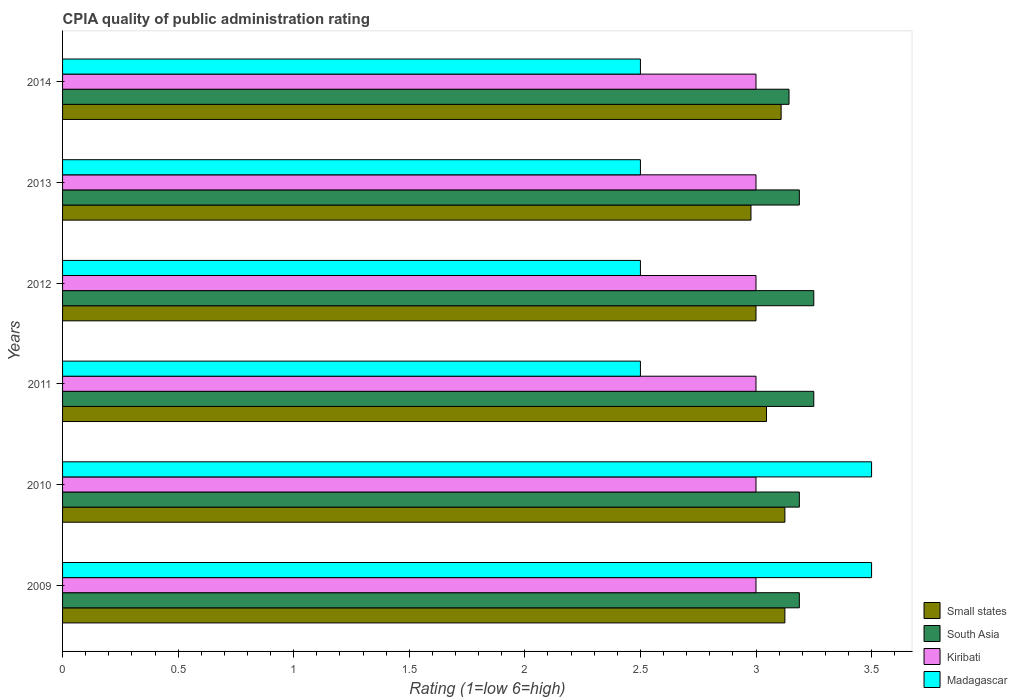How many groups of bars are there?
Give a very brief answer. 6. Are the number of bars per tick equal to the number of legend labels?
Keep it short and to the point. Yes. How many bars are there on the 6th tick from the top?
Give a very brief answer. 4. What is the label of the 1st group of bars from the top?
Keep it short and to the point. 2014. In how many cases, is the number of bars for a given year not equal to the number of legend labels?
Ensure brevity in your answer.  0. What is the CPIA rating in Madagascar in 2012?
Your answer should be compact. 2.5. Across all years, what is the maximum CPIA rating in Madagascar?
Your answer should be very brief. 3.5. Across all years, what is the minimum CPIA rating in Madagascar?
Ensure brevity in your answer.  2.5. What is the total CPIA rating in South Asia in the graph?
Offer a very short reply. 19.21. What is the difference between the CPIA rating in Small states in 2009 and that in 2014?
Offer a very short reply. 0.02. What is the average CPIA rating in Small states per year?
Make the answer very short. 3.06. In the year 2014, what is the difference between the CPIA rating in Kiribati and CPIA rating in South Asia?
Offer a terse response. -0.14. Is the difference between the CPIA rating in Kiribati in 2012 and 2014 greater than the difference between the CPIA rating in South Asia in 2012 and 2014?
Provide a short and direct response. No. What is the difference between the highest and the lowest CPIA rating in South Asia?
Keep it short and to the point. 0.11. In how many years, is the CPIA rating in Kiribati greater than the average CPIA rating in Kiribati taken over all years?
Provide a short and direct response. 0. What does the 1st bar from the top in 2011 represents?
Provide a succinct answer. Madagascar. What does the 3rd bar from the bottom in 2014 represents?
Ensure brevity in your answer.  Kiribati. Is it the case that in every year, the sum of the CPIA rating in Madagascar and CPIA rating in Small states is greater than the CPIA rating in South Asia?
Offer a terse response. Yes. How many bars are there?
Give a very brief answer. 24. Are all the bars in the graph horizontal?
Provide a succinct answer. Yes. Are the values on the major ticks of X-axis written in scientific E-notation?
Ensure brevity in your answer.  No. Does the graph contain any zero values?
Give a very brief answer. No. How are the legend labels stacked?
Provide a short and direct response. Vertical. What is the title of the graph?
Ensure brevity in your answer.  CPIA quality of public administration rating. Does "Grenada" appear as one of the legend labels in the graph?
Your answer should be compact. No. What is the label or title of the X-axis?
Keep it short and to the point. Rating (1=low 6=high). What is the label or title of the Y-axis?
Ensure brevity in your answer.  Years. What is the Rating (1=low 6=high) in Small states in 2009?
Your answer should be very brief. 3.12. What is the Rating (1=low 6=high) of South Asia in 2009?
Provide a succinct answer. 3.19. What is the Rating (1=low 6=high) of Madagascar in 2009?
Your answer should be very brief. 3.5. What is the Rating (1=low 6=high) in Small states in 2010?
Keep it short and to the point. 3.12. What is the Rating (1=low 6=high) in South Asia in 2010?
Provide a short and direct response. 3.19. What is the Rating (1=low 6=high) of Small states in 2011?
Offer a terse response. 3.05. What is the Rating (1=low 6=high) of South Asia in 2011?
Make the answer very short. 3.25. What is the Rating (1=low 6=high) of Madagascar in 2011?
Your answer should be very brief. 2.5. What is the Rating (1=low 6=high) of Small states in 2012?
Provide a short and direct response. 3. What is the Rating (1=low 6=high) in South Asia in 2012?
Your response must be concise. 3.25. What is the Rating (1=low 6=high) in Madagascar in 2012?
Your answer should be very brief. 2.5. What is the Rating (1=low 6=high) in Small states in 2013?
Make the answer very short. 2.98. What is the Rating (1=low 6=high) of South Asia in 2013?
Offer a very short reply. 3.19. What is the Rating (1=low 6=high) of Kiribati in 2013?
Give a very brief answer. 3. What is the Rating (1=low 6=high) of Madagascar in 2013?
Offer a very short reply. 2.5. What is the Rating (1=low 6=high) of Small states in 2014?
Your answer should be very brief. 3.11. What is the Rating (1=low 6=high) of South Asia in 2014?
Give a very brief answer. 3.14. What is the Rating (1=low 6=high) in Kiribati in 2014?
Provide a short and direct response. 3. What is the Rating (1=low 6=high) of Madagascar in 2014?
Your answer should be compact. 2.5. Across all years, what is the maximum Rating (1=low 6=high) in Small states?
Your response must be concise. 3.12. Across all years, what is the minimum Rating (1=low 6=high) in Small states?
Your answer should be very brief. 2.98. Across all years, what is the minimum Rating (1=low 6=high) in South Asia?
Ensure brevity in your answer.  3.14. What is the total Rating (1=low 6=high) of Small states in the graph?
Your answer should be compact. 18.38. What is the total Rating (1=low 6=high) in South Asia in the graph?
Give a very brief answer. 19.21. What is the total Rating (1=low 6=high) in Madagascar in the graph?
Offer a terse response. 17. What is the difference between the Rating (1=low 6=high) in Small states in 2009 and that in 2010?
Provide a succinct answer. 0. What is the difference between the Rating (1=low 6=high) of South Asia in 2009 and that in 2010?
Your response must be concise. 0. What is the difference between the Rating (1=low 6=high) of Madagascar in 2009 and that in 2010?
Your response must be concise. 0. What is the difference between the Rating (1=low 6=high) of Small states in 2009 and that in 2011?
Your answer should be compact. 0.08. What is the difference between the Rating (1=low 6=high) of South Asia in 2009 and that in 2011?
Ensure brevity in your answer.  -0.06. What is the difference between the Rating (1=low 6=high) in Madagascar in 2009 and that in 2011?
Your answer should be compact. 1. What is the difference between the Rating (1=low 6=high) in Small states in 2009 and that in 2012?
Offer a terse response. 0.12. What is the difference between the Rating (1=low 6=high) of South Asia in 2009 and that in 2012?
Give a very brief answer. -0.06. What is the difference between the Rating (1=low 6=high) in Kiribati in 2009 and that in 2012?
Give a very brief answer. 0. What is the difference between the Rating (1=low 6=high) of Small states in 2009 and that in 2013?
Your answer should be very brief. 0.15. What is the difference between the Rating (1=low 6=high) in Small states in 2009 and that in 2014?
Your response must be concise. 0.02. What is the difference between the Rating (1=low 6=high) in South Asia in 2009 and that in 2014?
Your answer should be compact. 0.04. What is the difference between the Rating (1=low 6=high) of Madagascar in 2009 and that in 2014?
Keep it short and to the point. 1. What is the difference between the Rating (1=low 6=high) of Small states in 2010 and that in 2011?
Provide a succinct answer. 0.08. What is the difference between the Rating (1=low 6=high) in South Asia in 2010 and that in 2011?
Provide a succinct answer. -0.06. What is the difference between the Rating (1=low 6=high) in South Asia in 2010 and that in 2012?
Your answer should be compact. -0.06. What is the difference between the Rating (1=low 6=high) in Small states in 2010 and that in 2013?
Keep it short and to the point. 0.15. What is the difference between the Rating (1=low 6=high) in Kiribati in 2010 and that in 2013?
Give a very brief answer. 0. What is the difference between the Rating (1=low 6=high) in Small states in 2010 and that in 2014?
Give a very brief answer. 0.02. What is the difference between the Rating (1=low 6=high) of South Asia in 2010 and that in 2014?
Give a very brief answer. 0.04. What is the difference between the Rating (1=low 6=high) of Small states in 2011 and that in 2012?
Keep it short and to the point. 0.05. What is the difference between the Rating (1=low 6=high) of Kiribati in 2011 and that in 2012?
Offer a terse response. 0. What is the difference between the Rating (1=low 6=high) in Madagascar in 2011 and that in 2012?
Offer a very short reply. 0. What is the difference between the Rating (1=low 6=high) of Small states in 2011 and that in 2013?
Keep it short and to the point. 0.07. What is the difference between the Rating (1=low 6=high) in South Asia in 2011 and that in 2013?
Make the answer very short. 0.06. What is the difference between the Rating (1=low 6=high) of Kiribati in 2011 and that in 2013?
Your response must be concise. 0. What is the difference between the Rating (1=low 6=high) in Small states in 2011 and that in 2014?
Your answer should be compact. -0.06. What is the difference between the Rating (1=low 6=high) of South Asia in 2011 and that in 2014?
Provide a short and direct response. 0.11. What is the difference between the Rating (1=low 6=high) in Kiribati in 2011 and that in 2014?
Your answer should be compact. 0. What is the difference between the Rating (1=low 6=high) of Madagascar in 2011 and that in 2014?
Your answer should be compact. 0. What is the difference between the Rating (1=low 6=high) in Small states in 2012 and that in 2013?
Give a very brief answer. 0.02. What is the difference between the Rating (1=low 6=high) in South Asia in 2012 and that in 2013?
Provide a short and direct response. 0.06. What is the difference between the Rating (1=low 6=high) in Madagascar in 2012 and that in 2013?
Ensure brevity in your answer.  0. What is the difference between the Rating (1=low 6=high) of Small states in 2012 and that in 2014?
Provide a short and direct response. -0.11. What is the difference between the Rating (1=low 6=high) in South Asia in 2012 and that in 2014?
Your answer should be very brief. 0.11. What is the difference between the Rating (1=low 6=high) of Small states in 2013 and that in 2014?
Your answer should be compact. -0.13. What is the difference between the Rating (1=low 6=high) in South Asia in 2013 and that in 2014?
Provide a short and direct response. 0.04. What is the difference between the Rating (1=low 6=high) of Kiribati in 2013 and that in 2014?
Make the answer very short. 0. What is the difference between the Rating (1=low 6=high) in Madagascar in 2013 and that in 2014?
Your response must be concise. 0. What is the difference between the Rating (1=low 6=high) in Small states in 2009 and the Rating (1=low 6=high) in South Asia in 2010?
Your answer should be very brief. -0.06. What is the difference between the Rating (1=low 6=high) of Small states in 2009 and the Rating (1=low 6=high) of Madagascar in 2010?
Make the answer very short. -0.38. What is the difference between the Rating (1=low 6=high) in South Asia in 2009 and the Rating (1=low 6=high) in Kiribati in 2010?
Provide a short and direct response. 0.19. What is the difference between the Rating (1=low 6=high) of South Asia in 2009 and the Rating (1=low 6=high) of Madagascar in 2010?
Make the answer very short. -0.31. What is the difference between the Rating (1=low 6=high) in Small states in 2009 and the Rating (1=low 6=high) in South Asia in 2011?
Offer a very short reply. -0.12. What is the difference between the Rating (1=low 6=high) in South Asia in 2009 and the Rating (1=low 6=high) in Kiribati in 2011?
Give a very brief answer. 0.19. What is the difference between the Rating (1=low 6=high) in South Asia in 2009 and the Rating (1=low 6=high) in Madagascar in 2011?
Provide a succinct answer. 0.69. What is the difference between the Rating (1=low 6=high) of Kiribati in 2009 and the Rating (1=low 6=high) of Madagascar in 2011?
Make the answer very short. 0.5. What is the difference between the Rating (1=low 6=high) of Small states in 2009 and the Rating (1=low 6=high) of South Asia in 2012?
Your response must be concise. -0.12. What is the difference between the Rating (1=low 6=high) in Small states in 2009 and the Rating (1=low 6=high) in Kiribati in 2012?
Provide a succinct answer. 0.12. What is the difference between the Rating (1=low 6=high) of South Asia in 2009 and the Rating (1=low 6=high) of Kiribati in 2012?
Keep it short and to the point. 0.19. What is the difference between the Rating (1=low 6=high) of South Asia in 2009 and the Rating (1=low 6=high) of Madagascar in 2012?
Give a very brief answer. 0.69. What is the difference between the Rating (1=low 6=high) in Small states in 2009 and the Rating (1=low 6=high) in South Asia in 2013?
Ensure brevity in your answer.  -0.06. What is the difference between the Rating (1=low 6=high) of South Asia in 2009 and the Rating (1=low 6=high) of Kiribati in 2013?
Your answer should be compact. 0.19. What is the difference between the Rating (1=low 6=high) in South Asia in 2009 and the Rating (1=low 6=high) in Madagascar in 2013?
Give a very brief answer. 0.69. What is the difference between the Rating (1=low 6=high) in Small states in 2009 and the Rating (1=low 6=high) in South Asia in 2014?
Give a very brief answer. -0.02. What is the difference between the Rating (1=low 6=high) in Small states in 2009 and the Rating (1=low 6=high) in Kiribati in 2014?
Your answer should be compact. 0.12. What is the difference between the Rating (1=low 6=high) in South Asia in 2009 and the Rating (1=low 6=high) in Kiribati in 2014?
Give a very brief answer. 0.19. What is the difference between the Rating (1=low 6=high) in South Asia in 2009 and the Rating (1=low 6=high) in Madagascar in 2014?
Your response must be concise. 0.69. What is the difference between the Rating (1=low 6=high) in Small states in 2010 and the Rating (1=low 6=high) in South Asia in 2011?
Your response must be concise. -0.12. What is the difference between the Rating (1=low 6=high) in Small states in 2010 and the Rating (1=low 6=high) in Kiribati in 2011?
Provide a succinct answer. 0.12. What is the difference between the Rating (1=low 6=high) in Small states in 2010 and the Rating (1=low 6=high) in Madagascar in 2011?
Offer a very short reply. 0.62. What is the difference between the Rating (1=low 6=high) of South Asia in 2010 and the Rating (1=low 6=high) of Kiribati in 2011?
Your response must be concise. 0.19. What is the difference between the Rating (1=low 6=high) in South Asia in 2010 and the Rating (1=low 6=high) in Madagascar in 2011?
Ensure brevity in your answer.  0.69. What is the difference between the Rating (1=low 6=high) of Small states in 2010 and the Rating (1=low 6=high) of South Asia in 2012?
Provide a short and direct response. -0.12. What is the difference between the Rating (1=low 6=high) in Small states in 2010 and the Rating (1=low 6=high) in Madagascar in 2012?
Provide a short and direct response. 0.62. What is the difference between the Rating (1=low 6=high) of South Asia in 2010 and the Rating (1=low 6=high) of Kiribati in 2012?
Keep it short and to the point. 0.19. What is the difference between the Rating (1=low 6=high) in South Asia in 2010 and the Rating (1=low 6=high) in Madagascar in 2012?
Your answer should be very brief. 0.69. What is the difference between the Rating (1=low 6=high) in Kiribati in 2010 and the Rating (1=low 6=high) in Madagascar in 2012?
Make the answer very short. 0.5. What is the difference between the Rating (1=low 6=high) of Small states in 2010 and the Rating (1=low 6=high) of South Asia in 2013?
Keep it short and to the point. -0.06. What is the difference between the Rating (1=low 6=high) of South Asia in 2010 and the Rating (1=low 6=high) of Kiribati in 2013?
Offer a very short reply. 0.19. What is the difference between the Rating (1=low 6=high) in South Asia in 2010 and the Rating (1=low 6=high) in Madagascar in 2013?
Make the answer very short. 0.69. What is the difference between the Rating (1=low 6=high) of Small states in 2010 and the Rating (1=low 6=high) of South Asia in 2014?
Ensure brevity in your answer.  -0.02. What is the difference between the Rating (1=low 6=high) in Small states in 2010 and the Rating (1=low 6=high) in Kiribati in 2014?
Give a very brief answer. 0.12. What is the difference between the Rating (1=low 6=high) of South Asia in 2010 and the Rating (1=low 6=high) of Kiribati in 2014?
Offer a terse response. 0.19. What is the difference between the Rating (1=low 6=high) of South Asia in 2010 and the Rating (1=low 6=high) of Madagascar in 2014?
Keep it short and to the point. 0.69. What is the difference between the Rating (1=low 6=high) in Small states in 2011 and the Rating (1=low 6=high) in South Asia in 2012?
Make the answer very short. -0.2. What is the difference between the Rating (1=low 6=high) in Small states in 2011 and the Rating (1=low 6=high) in Kiribati in 2012?
Offer a very short reply. 0.05. What is the difference between the Rating (1=low 6=high) of Small states in 2011 and the Rating (1=low 6=high) of Madagascar in 2012?
Your answer should be very brief. 0.55. What is the difference between the Rating (1=low 6=high) of South Asia in 2011 and the Rating (1=low 6=high) of Kiribati in 2012?
Your answer should be very brief. 0.25. What is the difference between the Rating (1=low 6=high) in South Asia in 2011 and the Rating (1=low 6=high) in Madagascar in 2012?
Provide a succinct answer. 0.75. What is the difference between the Rating (1=low 6=high) of Kiribati in 2011 and the Rating (1=low 6=high) of Madagascar in 2012?
Keep it short and to the point. 0.5. What is the difference between the Rating (1=low 6=high) of Small states in 2011 and the Rating (1=low 6=high) of South Asia in 2013?
Offer a terse response. -0.14. What is the difference between the Rating (1=low 6=high) of Small states in 2011 and the Rating (1=low 6=high) of Kiribati in 2013?
Make the answer very short. 0.05. What is the difference between the Rating (1=low 6=high) of Small states in 2011 and the Rating (1=low 6=high) of Madagascar in 2013?
Keep it short and to the point. 0.55. What is the difference between the Rating (1=low 6=high) in South Asia in 2011 and the Rating (1=low 6=high) in Kiribati in 2013?
Keep it short and to the point. 0.25. What is the difference between the Rating (1=low 6=high) of Small states in 2011 and the Rating (1=low 6=high) of South Asia in 2014?
Ensure brevity in your answer.  -0.1. What is the difference between the Rating (1=low 6=high) of Small states in 2011 and the Rating (1=low 6=high) of Kiribati in 2014?
Offer a very short reply. 0.05. What is the difference between the Rating (1=low 6=high) in Small states in 2011 and the Rating (1=low 6=high) in Madagascar in 2014?
Offer a very short reply. 0.55. What is the difference between the Rating (1=low 6=high) of South Asia in 2011 and the Rating (1=low 6=high) of Kiribati in 2014?
Offer a very short reply. 0.25. What is the difference between the Rating (1=low 6=high) in Kiribati in 2011 and the Rating (1=low 6=high) in Madagascar in 2014?
Keep it short and to the point. 0.5. What is the difference between the Rating (1=low 6=high) in Small states in 2012 and the Rating (1=low 6=high) in South Asia in 2013?
Your response must be concise. -0.19. What is the difference between the Rating (1=low 6=high) in Small states in 2012 and the Rating (1=low 6=high) in Kiribati in 2013?
Offer a terse response. 0. What is the difference between the Rating (1=low 6=high) in Kiribati in 2012 and the Rating (1=low 6=high) in Madagascar in 2013?
Ensure brevity in your answer.  0.5. What is the difference between the Rating (1=low 6=high) in Small states in 2012 and the Rating (1=low 6=high) in South Asia in 2014?
Provide a short and direct response. -0.14. What is the difference between the Rating (1=low 6=high) in Small states in 2012 and the Rating (1=low 6=high) in Madagascar in 2014?
Your response must be concise. 0.5. What is the difference between the Rating (1=low 6=high) of South Asia in 2012 and the Rating (1=low 6=high) of Kiribati in 2014?
Offer a terse response. 0.25. What is the difference between the Rating (1=low 6=high) in South Asia in 2012 and the Rating (1=low 6=high) in Madagascar in 2014?
Offer a terse response. 0.75. What is the difference between the Rating (1=low 6=high) of Small states in 2013 and the Rating (1=low 6=high) of South Asia in 2014?
Make the answer very short. -0.16. What is the difference between the Rating (1=low 6=high) of Small states in 2013 and the Rating (1=low 6=high) of Kiribati in 2014?
Give a very brief answer. -0.02. What is the difference between the Rating (1=low 6=high) of Small states in 2013 and the Rating (1=low 6=high) of Madagascar in 2014?
Provide a short and direct response. 0.48. What is the difference between the Rating (1=low 6=high) in South Asia in 2013 and the Rating (1=low 6=high) in Kiribati in 2014?
Give a very brief answer. 0.19. What is the difference between the Rating (1=low 6=high) in South Asia in 2013 and the Rating (1=low 6=high) in Madagascar in 2014?
Your answer should be very brief. 0.69. What is the average Rating (1=low 6=high) of Small states per year?
Make the answer very short. 3.06. What is the average Rating (1=low 6=high) in South Asia per year?
Keep it short and to the point. 3.2. What is the average Rating (1=low 6=high) of Kiribati per year?
Your answer should be very brief. 3. What is the average Rating (1=low 6=high) in Madagascar per year?
Give a very brief answer. 2.83. In the year 2009, what is the difference between the Rating (1=low 6=high) of Small states and Rating (1=low 6=high) of South Asia?
Provide a short and direct response. -0.06. In the year 2009, what is the difference between the Rating (1=low 6=high) in Small states and Rating (1=low 6=high) in Madagascar?
Offer a very short reply. -0.38. In the year 2009, what is the difference between the Rating (1=low 6=high) in South Asia and Rating (1=low 6=high) in Kiribati?
Your response must be concise. 0.19. In the year 2009, what is the difference between the Rating (1=low 6=high) of South Asia and Rating (1=low 6=high) of Madagascar?
Your response must be concise. -0.31. In the year 2009, what is the difference between the Rating (1=low 6=high) of Kiribati and Rating (1=low 6=high) of Madagascar?
Your answer should be very brief. -0.5. In the year 2010, what is the difference between the Rating (1=low 6=high) in Small states and Rating (1=low 6=high) in South Asia?
Offer a very short reply. -0.06. In the year 2010, what is the difference between the Rating (1=low 6=high) of Small states and Rating (1=low 6=high) of Kiribati?
Your answer should be very brief. 0.12. In the year 2010, what is the difference between the Rating (1=low 6=high) of Small states and Rating (1=low 6=high) of Madagascar?
Keep it short and to the point. -0.38. In the year 2010, what is the difference between the Rating (1=low 6=high) of South Asia and Rating (1=low 6=high) of Kiribati?
Provide a short and direct response. 0.19. In the year 2010, what is the difference between the Rating (1=low 6=high) of South Asia and Rating (1=low 6=high) of Madagascar?
Offer a very short reply. -0.31. In the year 2011, what is the difference between the Rating (1=low 6=high) of Small states and Rating (1=low 6=high) of South Asia?
Provide a succinct answer. -0.2. In the year 2011, what is the difference between the Rating (1=low 6=high) in Small states and Rating (1=low 6=high) in Kiribati?
Your answer should be very brief. 0.05. In the year 2011, what is the difference between the Rating (1=low 6=high) in Small states and Rating (1=low 6=high) in Madagascar?
Give a very brief answer. 0.55. In the year 2011, what is the difference between the Rating (1=low 6=high) in South Asia and Rating (1=low 6=high) in Madagascar?
Keep it short and to the point. 0.75. In the year 2011, what is the difference between the Rating (1=low 6=high) of Kiribati and Rating (1=low 6=high) of Madagascar?
Keep it short and to the point. 0.5. In the year 2012, what is the difference between the Rating (1=low 6=high) of Small states and Rating (1=low 6=high) of Kiribati?
Ensure brevity in your answer.  0. In the year 2012, what is the difference between the Rating (1=low 6=high) of South Asia and Rating (1=low 6=high) of Kiribati?
Provide a succinct answer. 0.25. In the year 2012, what is the difference between the Rating (1=low 6=high) of Kiribati and Rating (1=low 6=high) of Madagascar?
Offer a terse response. 0.5. In the year 2013, what is the difference between the Rating (1=low 6=high) of Small states and Rating (1=low 6=high) of South Asia?
Your answer should be compact. -0.21. In the year 2013, what is the difference between the Rating (1=low 6=high) in Small states and Rating (1=low 6=high) in Kiribati?
Your response must be concise. -0.02. In the year 2013, what is the difference between the Rating (1=low 6=high) of Small states and Rating (1=low 6=high) of Madagascar?
Your answer should be very brief. 0.48. In the year 2013, what is the difference between the Rating (1=low 6=high) in South Asia and Rating (1=low 6=high) in Kiribati?
Give a very brief answer. 0.19. In the year 2013, what is the difference between the Rating (1=low 6=high) in South Asia and Rating (1=low 6=high) in Madagascar?
Make the answer very short. 0.69. In the year 2013, what is the difference between the Rating (1=low 6=high) in Kiribati and Rating (1=low 6=high) in Madagascar?
Provide a short and direct response. 0.5. In the year 2014, what is the difference between the Rating (1=low 6=high) of Small states and Rating (1=low 6=high) of South Asia?
Your answer should be compact. -0.03. In the year 2014, what is the difference between the Rating (1=low 6=high) in Small states and Rating (1=low 6=high) in Kiribati?
Offer a very short reply. 0.11. In the year 2014, what is the difference between the Rating (1=low 6=high) in Small states and Rating (1=low 6=high) in Madagascar?
Provide a short and direct response. 0.61. In the year 2014, what is the difference between the Rating (1=low 6=high) of South Asia and Rating (1=low 6=high) of Kiribati?
Your response must be concise. 0.14. In the year 2014, what is the difference between the Rating (1=low 6=high) of South Asia and Rating (1=low 6=high) of Madagascar?
Keep it short and to the point. 0.64. What is the ratio of the Rating (1=low 6=high) in Small states in 2009 to that in 2010?
Your answer should be compact. 1. What is the ratio of the Rating (1=low 6=high) in South Asia in 2009 to that in 2010?
Give a very brief answer. 1. What is the ratio of the Rating (1=low 6=high) of Kiribati in 2009 to that in 2010?
Make the answer very short. 1. What is the ratio of the Rating (1=low 6=high) in Madagascar in 2009 to that in 2010?
Offer a very short reply. 1. What is the ratio of the Rating (1=low 6=high) of Small states in 2009 to that in 2011?
Offer a terse response. 1.03. What is the ratio of the Rating (1=low 6=high) in South Asia in 2009 to that in 2011?
Offer a very short reply. 0.98. What is the ratio of the Rating (1=low 6=high) of Small states in 2009 to that in 2012?
Offer a terse response. 1.04. What is the ratio of the Rating (1=low 6=high) in South Asia in 2009 to that in 2012?
Give a very brief answer. 0.98. What is the ratio of the Rating (1=low 6=high) in Madagascar in 2009 to that in 2012?
Provide a short and direct response. 1.4. What is the ratio of the Rating (1=low 6=high) in Small states in 2009 to that in 2013?
Your answer should be very brief. 1.05. What is the ratio of the Rating (1=low 6=high) in Kiribati in 2009 to that in 2013?
Your answer should be compact. 1. What is the ratio of the Rating (1=low 6=high) in Madagascar in 2009 to that in 2013?
Make the answer very short. 1.4. What is the ratio of the Rating (1=low 6=high) of South Asia in 2009 to that in 2014?
Offer a terse response. 1.01. What is the ratio of the Rating (1=low 6=high) of Kiribati in 2009 to that in 2014?
Provide a short and direct response. 1. What is the ratio of the Rating (1=low 6=high) of Small states in 2010 to that in 2011?
Provide a short and direct response. 1.03. What is the ratio of the Rating (1=low 6=high) of South Asia in 2010 to that in 2011?
Your answer should be compact. 0.98. What is the ratio of the Rating (1=low 6=high) in Madagascar in 2010 to that in 2011?
Keep it short and to the point. 1.4. What is the ratio of the Rating (1=low 6=high) in Small states in 2010 to that in 2012?
Give a very brief answer. 1.04. What is the ratio of the Rating (1=low 6=high) in South Asia in 2010 to that in 2012?
Provide a short and direct response. 0.98. What is the ratio of the Rating (1=low 6=high) of Kiribati in 2010 to that in 2012?
Offer a very short reply. 1. What is the ratio of the Rating (1=low 6=high) in Small states in 2010 to that in 2013?
Ensure brevity in your answer.  1.05. What is the ratio of the Rating (1=low 6=high) in South Asia in 2010 to that in 2013?
Give a very brief answer. 1. What is the ratio of the Rating (1=low 6=high) in South Asia in 2010 to that in 2014?
Give a very brief answer. 1.01. What is the ratio of the Rating (1=low 6=high) of Madagascar in 2010 to that in 2014?
Give a very brief answer. 1.4. What is the ratio of the Rating (1=low 6=high) in Small states in 2011 to that in 2012?
Your response must be concise. 1.02. What is the ratio of the Rating (1=low 6=high) in Madagascar in 2011 to that in 2012?
Your response must be concise. 1. What is the ratio of the Rating (1=low 6=high) in Small states in 2011 to that in 2013?
Keep it short and to the point. 1.02. What is the ratio of the Rating (1=low 6=high) of South Asia in 2011 to that in 2013?
Provide a succinct answer. 1.02. What is the ratio of the Rating (1=low 6=high) in Kiribati in 2011 to that in 2013?
Ensure brevity in your answer.  1. What is the ratio of the Rating (1=low 6=high) in Madagascar in 2011 to that in 2013?
Your answer should be very brief. 1. What is the ratio of the Rating (1=low 6=high) of Small states in 2011 to that in 2014?
Offer a very short reply. 0.98. What is the ratio of the Rating (1=low 6=high) in South Asia in 2011 to that in 2014?
Your answer should be compact. 1.03. What is the ratio of the Rating (1=low 6=high) in Small states in 2012 to that in 2013?
Keep it short and to the point. 1.01. What is the ratio of the Rating (1=low 6=high) in South Asia in 2012 to that in 2013?
Provide a short and direct response. 1.02. What is the ratio of the Rating (1=low 6=high) in Small states in 2012 to that in 2014?
Give a very brief answer. 0.96. What is the ratio of the Rating (1=low 6=high) of South Asia in 2012 to that in 2014?
Your response must be concise. 1.03. What is the ratio of the Rating (1=low 6=high) in Kiribati in 2012 to that in 2014?
Provide a short and direct response. 1. What is the ratio of the Rating (1=low 6=high) of Madagascar in 2012 to that in 2014?
Provide a succinct answer. 1. What is the ratio of the Rating (1=low 6=high) in Small states in 2013 to that in 2014?
Offer a terse response. 0.96. What is the ratio of the Rating (1=low 6=high) of South Asia in 2013 to that in 2014?
Your response must be concise. 1.01. What is the ratio of the Rating (1=low 6=high) of Kiribati in 2013 to that in 2014?
Offer a terse response. 1. What is the difference between the highest and the second highest Rating (1=low 6=high) of South Asia?
Your answer should be compact. 0. What is the difference between the highest and the second highest Rating (1=low 6=high) of Madagascar?
Give a very brief answer. 0. What is the difference between the highest and the lowest Rating (1=low 6=high) of Small states?
Your answer should be very brief. 0.15. What is the difference between the highest and the lowest Rating (1=low 6=high) in South Asia?
Give a very brief answer. 0.11. What is the difference between the highest and the lowest Rating (1=low 6=high) in Kiribati?
Your answer should be very brief. 0. What is the difference between the highest and the lowest Rating (1=low 6=high) in Madagascar?
Your answer should be compact. 1. 